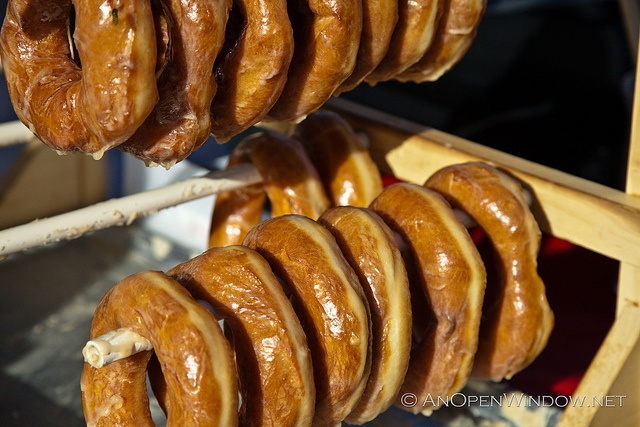Describe the objects in this image and their specific colors. I can see donut in black, brown, maroon, and salmon tones, donut in black, red, tan, and orange tones, donut in black, olive, maroon, and tan tones, donut in black, red, tan, and maroon tones, and donut in black, red, maroon, and tan tones in this image. 